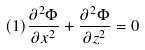<formula> <loc_0><loc_0><loc_500><loc_500>( 1 ) \frac { \partial ^ { 2 } \Phi } { \partial x ^ { 2 } } + \frac { \partial ^ { 2 } \Phi } { \partial z ^ { 2 } } = 0</formula> 